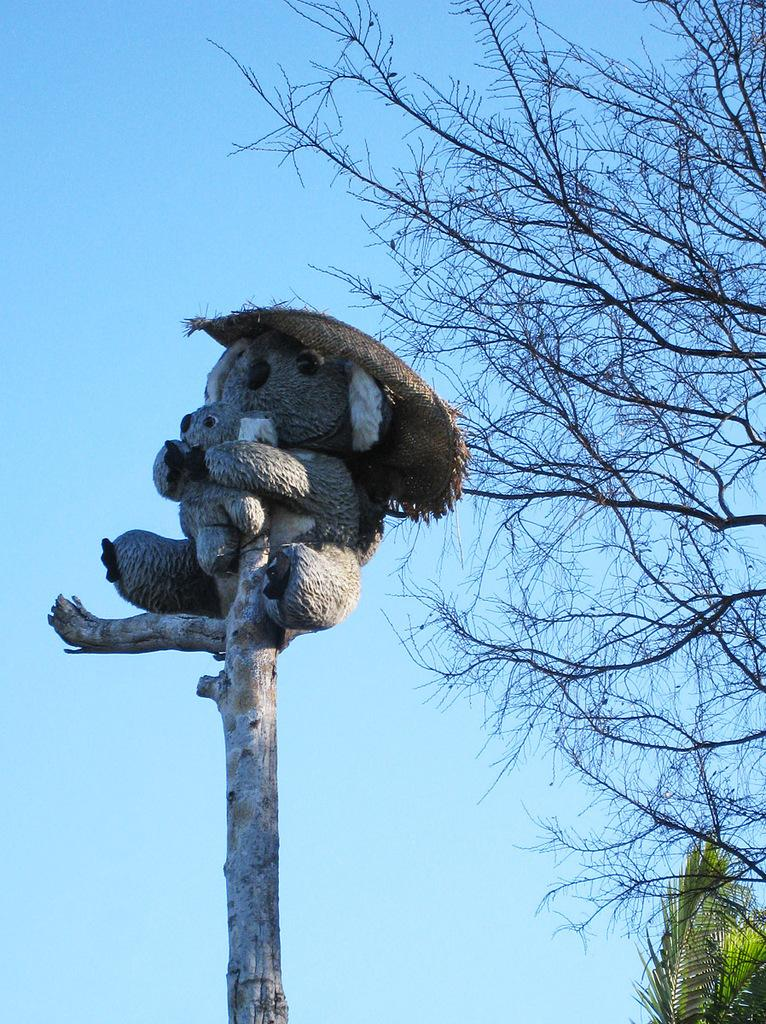What material is featured in the image? There is wood in the image. What object is placed on the wood? A teddy bear is present on the wood. What type of natural environment can be seen in the image? There are trees visible in the image. What is visible in the background of the image? The sky is visible in the background of the image. What type of operation is being performed on the teddy bear in the image? There is no operation being performed on the teddy bear in the image; it is simply placed on the wood. 